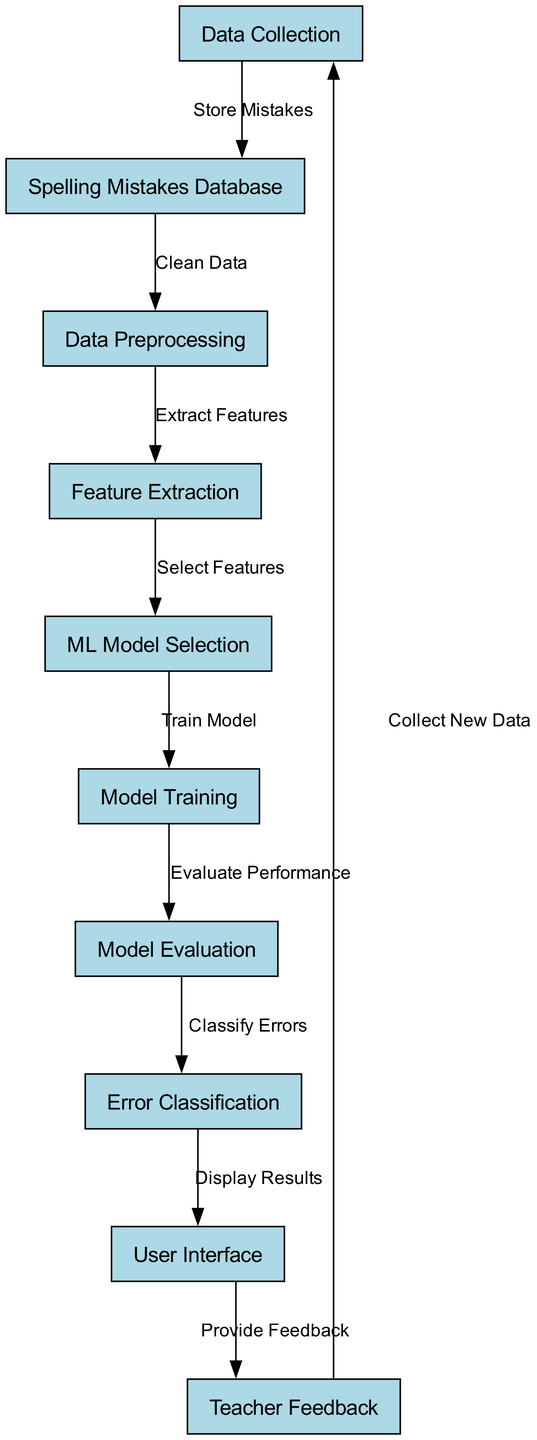What is the first step in the diagram? The first step shown in the diagram is labeled "Data Collection." This step initiates the process by collecting spelling mistake data.
Answer: Data Collection How many nodes are present in the diagram? By counting all the unique nodes displayed in the diagram, there are a total of ten nodes representing different tasks and processes.
Answer: 10 What is the last step before feedback is provided to the teacher? The diagram indicates that the last step before teacher feedback is "User Interface," where results are displayed for the teacher's interaction.
Answer: User Interface Which node comes directly after data preprocessing? After "Data Preprocessing," the next node in the flow is "Feature Extraction," indicating that this step follows immediately after cleaning the data.
Answer: Feature Extraction What action is taken after the model evaluation? Following the "Model Evaluation," the action taken is "Error Classification," where identified spelling errors are categorized.
Answer: Error Classification What is the relationship between the "Teacher Feedback" node and "Data Collection"? The relationship is cyclical; "Teacher Feedback" leads back to "Data Collection," suggesting that feedback can be used to improve further data collection efforts.
Answer: Collect New Data Which step involves training the machine learning model? The step labeled "Model Training" is where the machine learning model is trained using the selected features from previous steps.
Answer: Model Training How many edges link the nodes in the diagram? By counting the connections (edges) that connect the nodes, there are a total of nine edges showing the flow between different processes.
Answer: 9 What process occurs after the ML model selection? After "ML Model Selection," the process that occurs is "Model Training," which involves using the selected model to learn from training data.
Answer: Model Training 